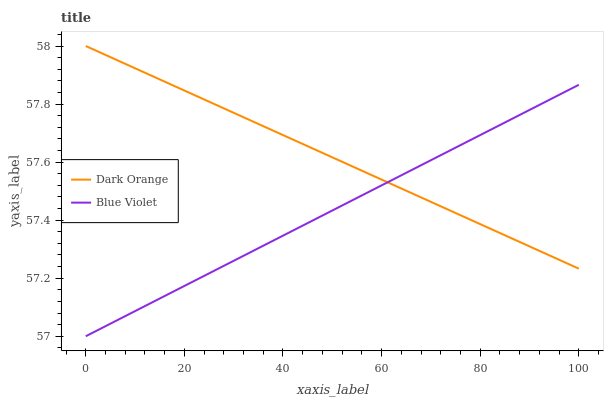Does Blue Violet have the minimum area under the curve?
Answer yes or no. Yes. Does Dark Orange have the maximum area under the curve?
Answer yes or no. Yes. Does Blue Violet have the maximum area under the curve?
Answer yes or no. No. Is Blue Violet the smoothest?
Answer yes or no. Yes. Is Dark Orange the roughest?
Answer yes or no. Yes. Is Blue Violet the roughest?
Answer yes or no. No. Does Blue Violet have the highest value?
Answer yes or no. No. 